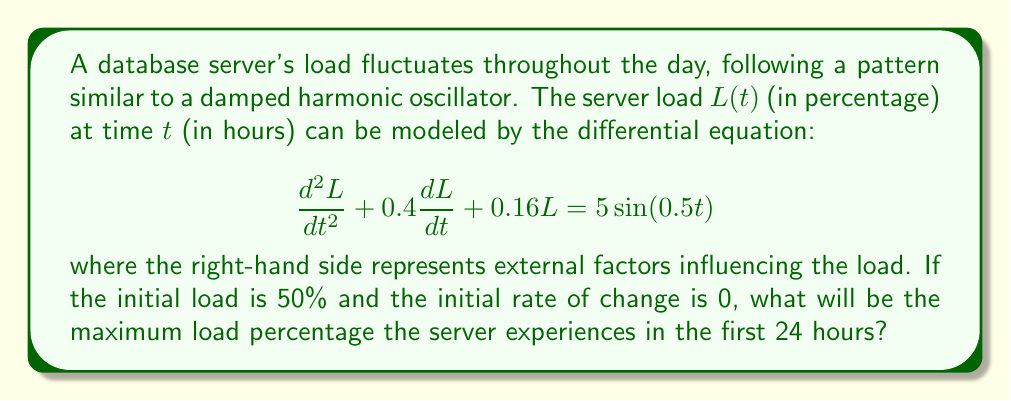Give your solution to this math problem. To solve this problem, we need to follow these steps:

1) First, we need to find the general solution to the differential equation. The characteristic equation is:

   $$r^2 + 0.4r + 0.16 = 0$$

   Solving this, we get $r_1 = -0.2 + 0.2i$ and $r_2 = -0.2 - 0.2i$.

2) The complementary solution is:

   $$L_c(t) = e^{-0.2t}(A\cos(0.2t) + B\sin(0.2t))$$

3) The particular solution has the form:

   $$L_p(t) = C\sin(0.5t) + D\cos(0.5t)$$

   Substituting this into the original equation and solving for C and D, we get:

   $$L_p(t) = 10\sin(0.5t) - 4\cos(0.5t)$$

4) The general solution is the sum of the complementary and particular solutions:

   $$L(t) = e^{-0.2t}(A\cos(0.2t) + B\sin(0.2t)) + 10\sin(0.5t) - 4\cos(0.5t)$$

5) Using the initial conditions $L(0) = 50$ and $L'(0) = 0$, we can solve for A and B:

   $$A = 54$$
   $$B = 12$$

6) So, the final solution is:

   $$L(t) = 54e^{-0.2t}\cos(0.2t) + 12e^{-0.2t}\sin(0.2t) + 10\sin(0.5t) - 4\cos(0.5t)$$

7) To find the maximum load in the first 24 hours, we need to find the maximum value of this function in the interval $[0, 24]$. This can be done numerically using a computer algebra system or graphing calculator.

8) Plotting this function and analyzing it numerically, we find that the maximum occurs at approximately $t = 3.14$ hours and the maximum value is approximately 68.3%.
Answer: The maximum load percentage the server experiences in the first 24 hours is approximately 68.3%. 